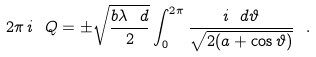<formula> <loc_0><loc_0><loc_500><loc_500>2 \pi \, i \ Q = \pm \sqrt { \frac { b \lambda \ d } { 2 } } \int _ { 0 } ^ { 2 \pi } \frac { i \ d \vartheta } { \sqrt { 2 ( a + \cos { \vartheta } ) } } \ .</formula> 